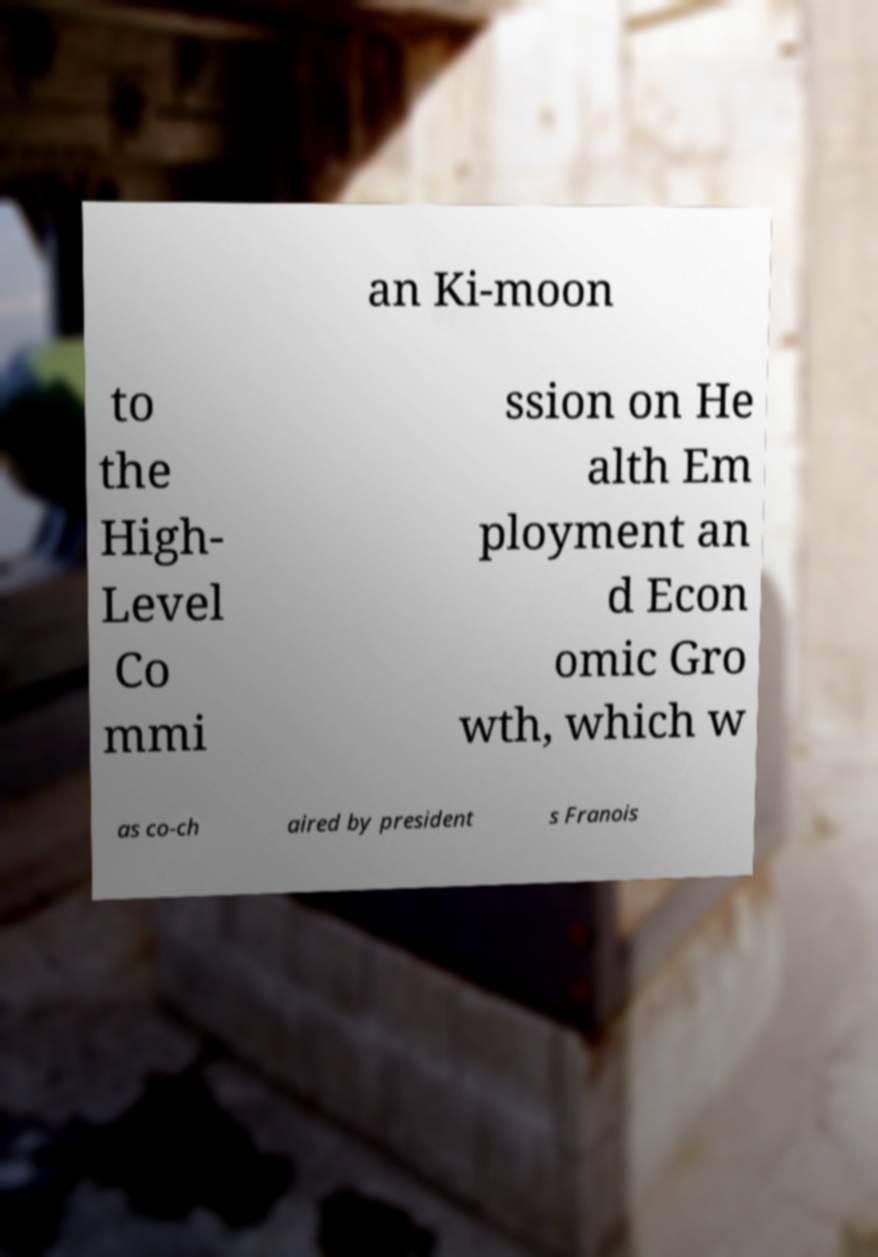Please read and relay the text visible in this image. What does it say? an Ki-moon to the High- Level Co mmi ssion on He alth Em ployment an d Econ omic Gro wth, which w as co-ch aired by president s Franois 